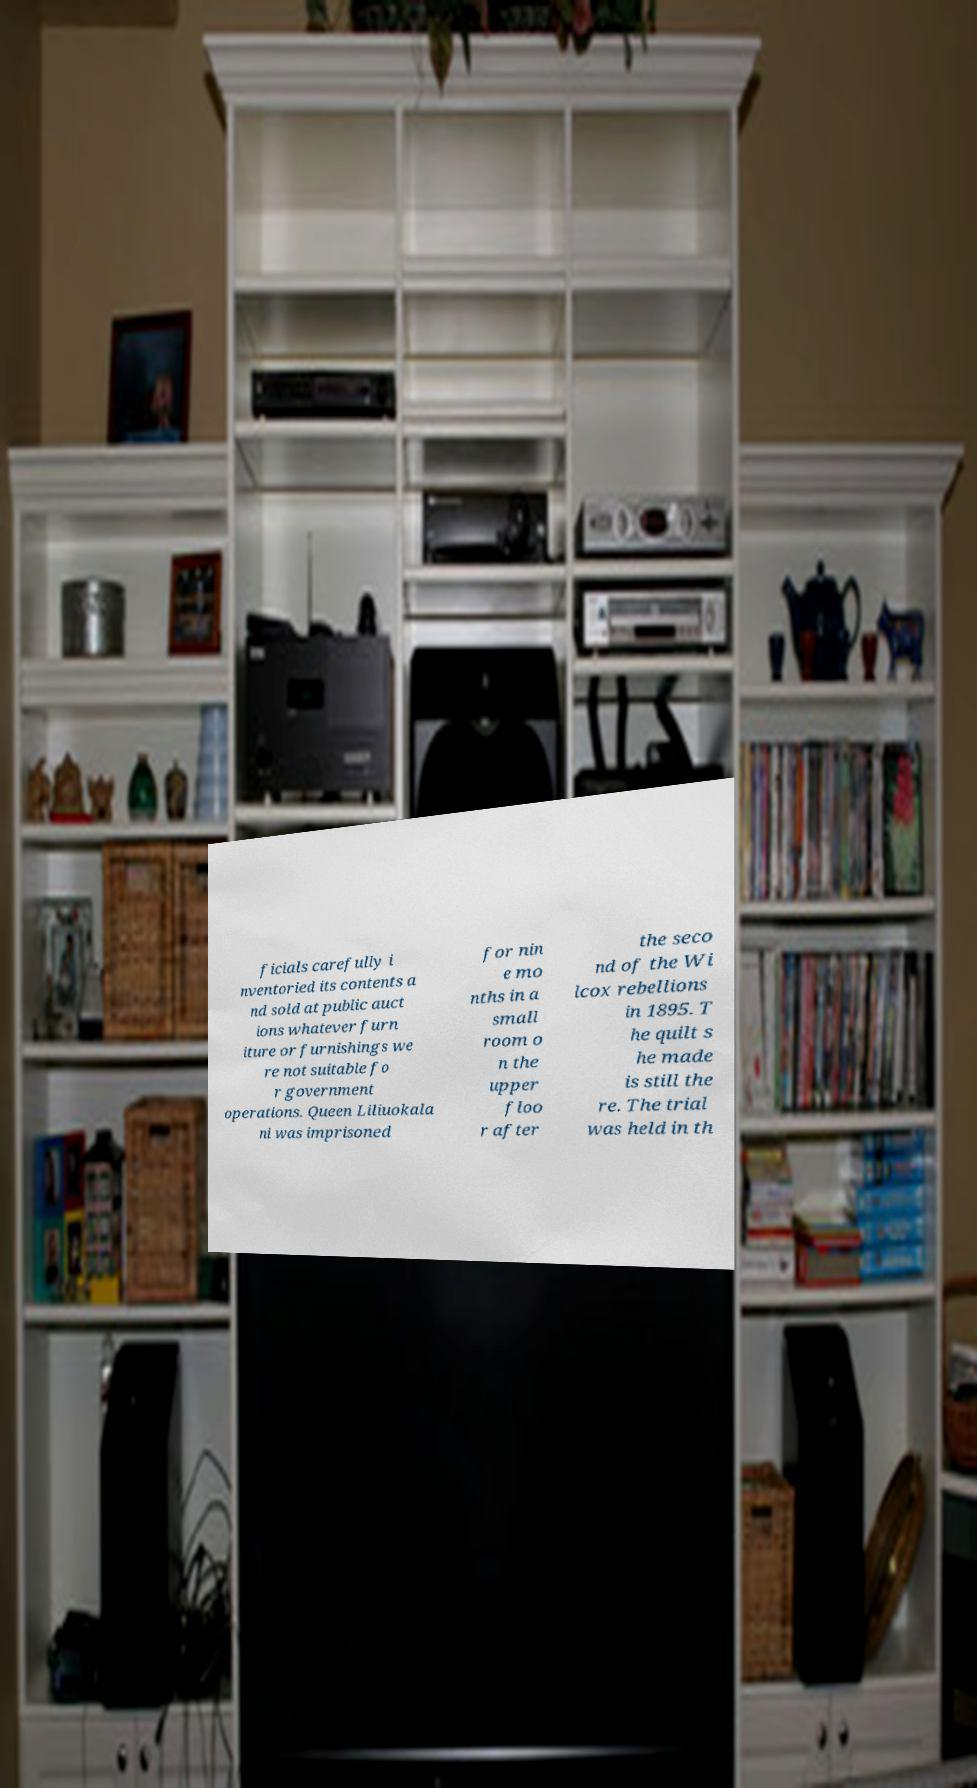I need the written content from this picture converted into text. Can you do that? ficials carefully i nventoried its contents a nd sold at public auct ions whatever furn iture or furnishings we re not suitable fo r government operations. Queen Liliuokala ni was imprisoned for nin e mo nths in a small room o n the upper floo r after the seco nd of the Wi lcox rebellions in 1895. T he quilt s he made is still the re. The trial was held in th 